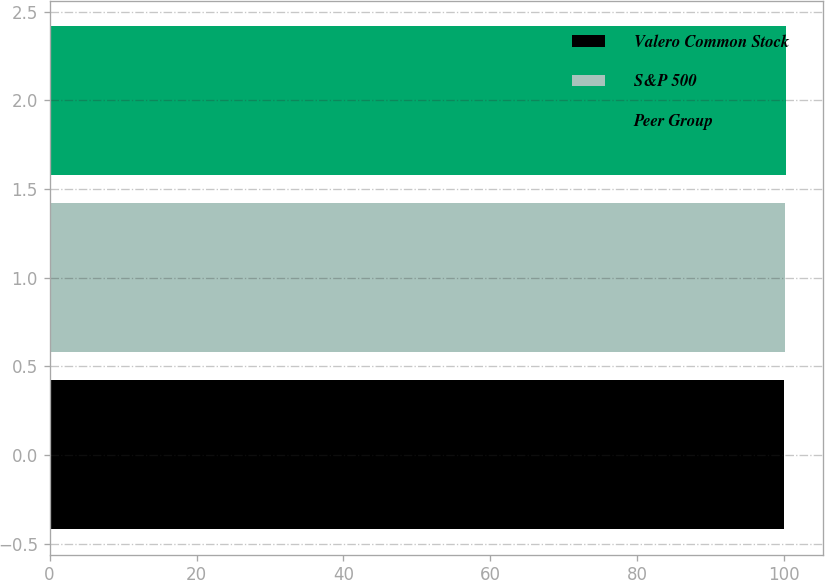Convert chart. <chart><loc_0><loc_0><loc_500><loc_500><bar_chart><fcel>Valero Common Stock<fcel>S&P 500<fcel>Peer Group<nl><fcel>100<fcel>100.1<fcel>100.2<nl></chart> 